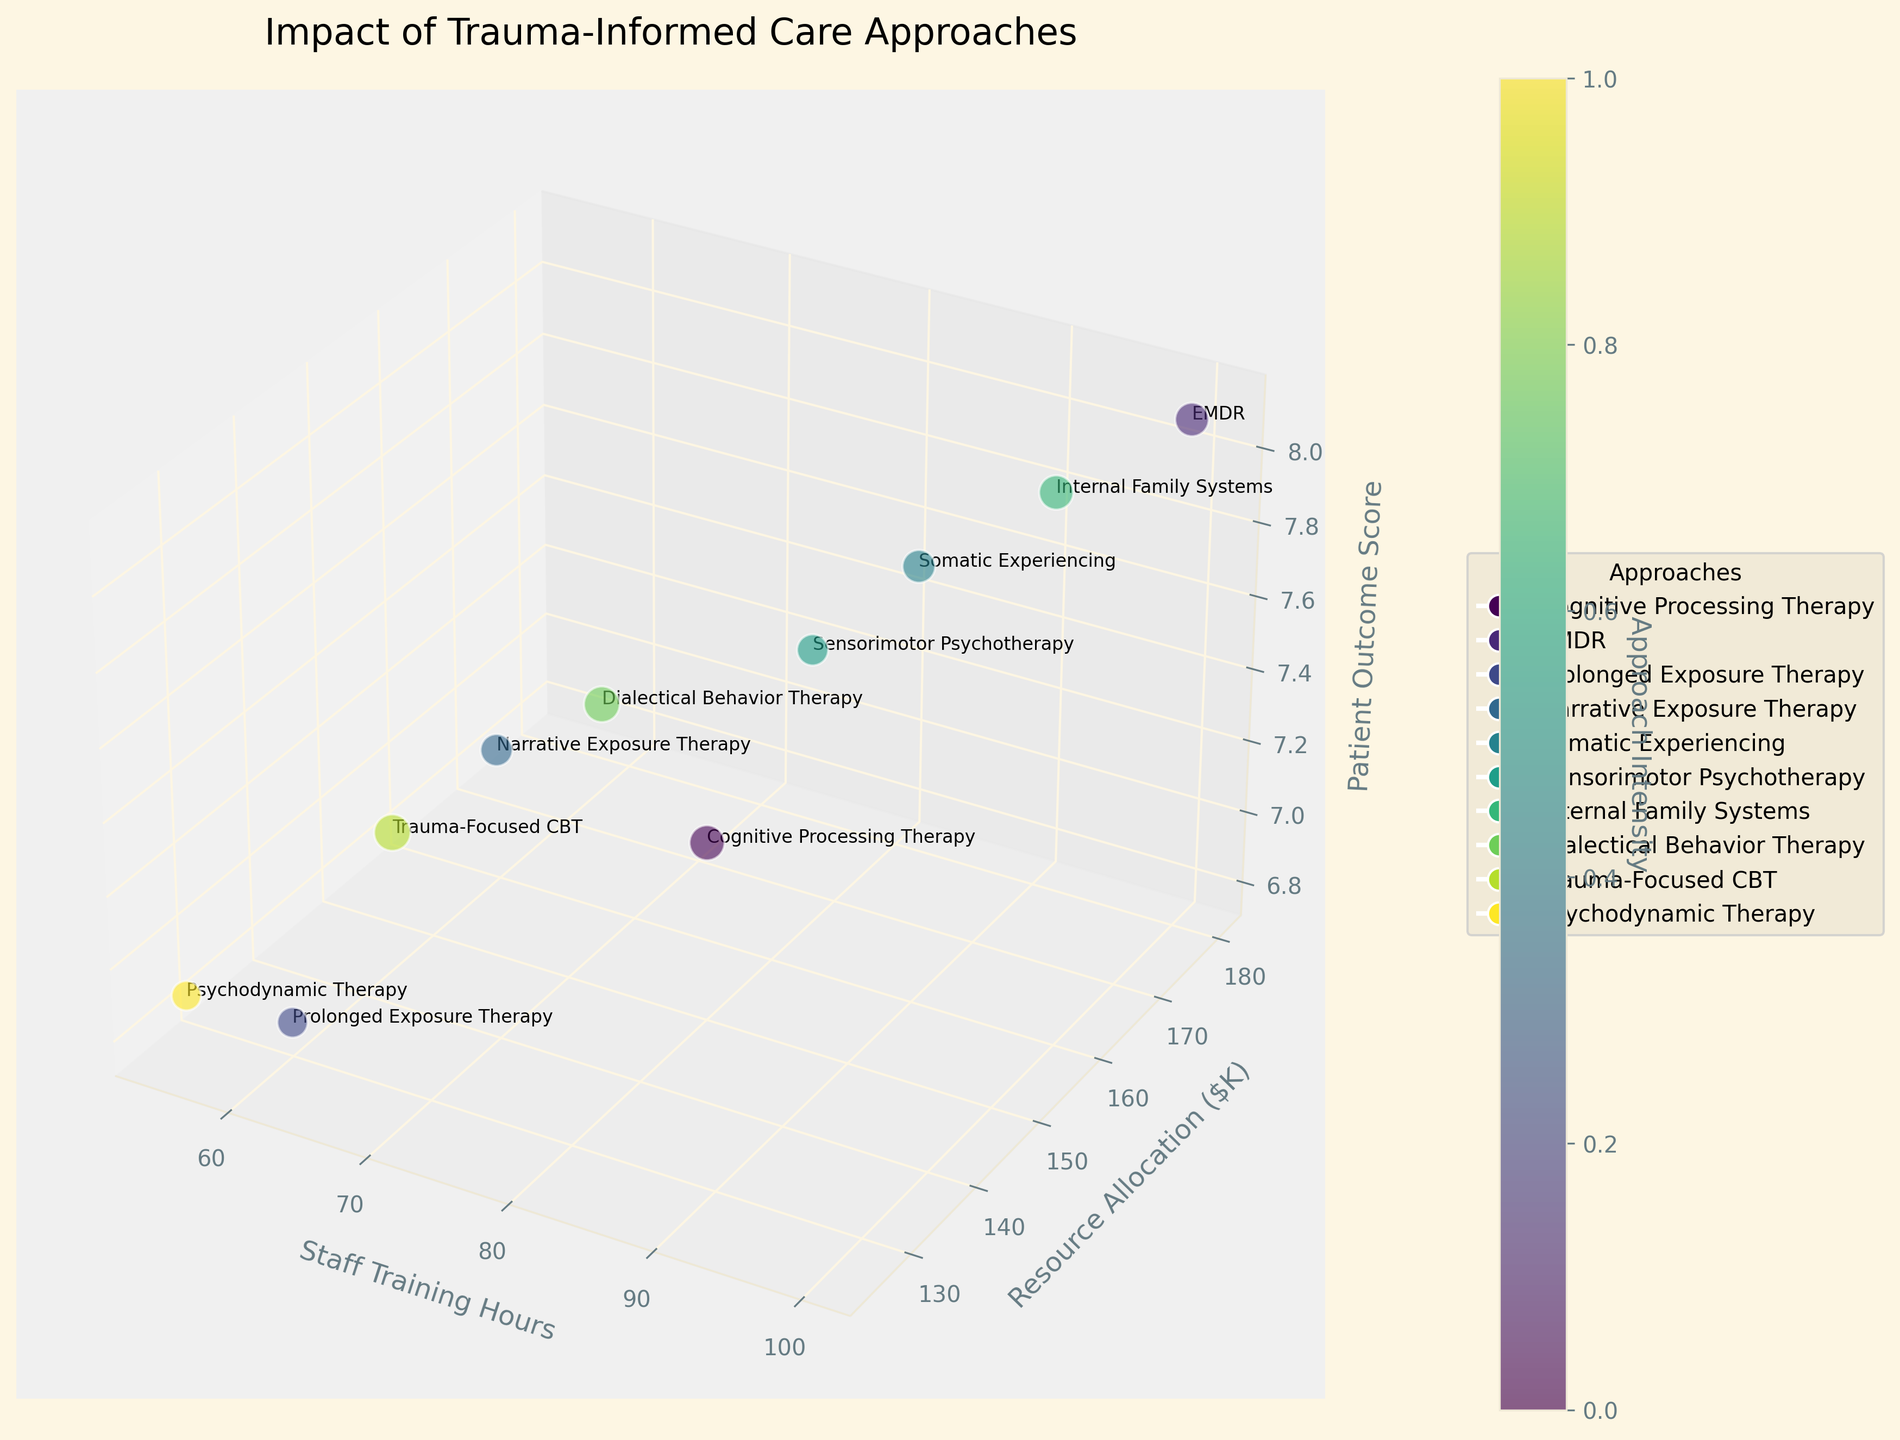What does the title of the figure indicate? The title is located at the top of the figure and provides a summary of the visual representation. From the title, we can infer that the figure is about how various trauma-informed care approaches impact patient outcomes, staff training levels, and clinic resources.
Answer: Impact of Trauma-Informed Care Approaches How many trauma-informed care approaches are represented in the figure? By counting the legend elements or the data points, we can determine how many different approaches are included.
Answer: 10 Which approach requires the most staff training hours, and how many hours are those? By checking the x-axis for the highest value and identifying the corresponding data point and label, we can find the answer.
Answer: EMDR, 100 hours Which approach has the highest patient outcome score? By observing the z-axis and finding the highest data point, we can identify which approach has the top score for patient outcomes.
Answer: EMDR What is the average patient outcome score across all approaches? Sum up all patient outcome scores and divide by the total number of approaches: (7.2 + 8.1 + 6.8 + 7.5 + 7.9 + 7.7 + 8.0 + 7.6 + 7.3 + 6.9) / 10.
Answer: 7.6 Compare the patient outcome scores of EMDR and Psychodynamic Therapy. Which one is higher, and by how much? Identify the scores for both approaches (EMDR: 8.1, Psychodynamic Therapy: 6.9) and subtract the lower from the higher to find the difference.
Answer: EMDR, by 1.2 Which approach serves the largest number of patients, and how many patients are served by that approach? The approach serving the largest number of patients can be identified by finding the biggest bubble size and checking the correspondence with the legend or the texts near the bubbles.
Answer: Trauma-Focused CBT, 130 patients Does an increase in staff training hours correlate with better patient outcome scores? Look for a trend along the x and z axes to examine if higher staff training corresponds with higher patient outcome scores.
Answer: Generally, yes Which approach has the highest resource allocation, and what is the allocated amount in $K? Find the highest value on the y-axis and identify the corresponding data point and its label.
Answer: EMDR, $180K 